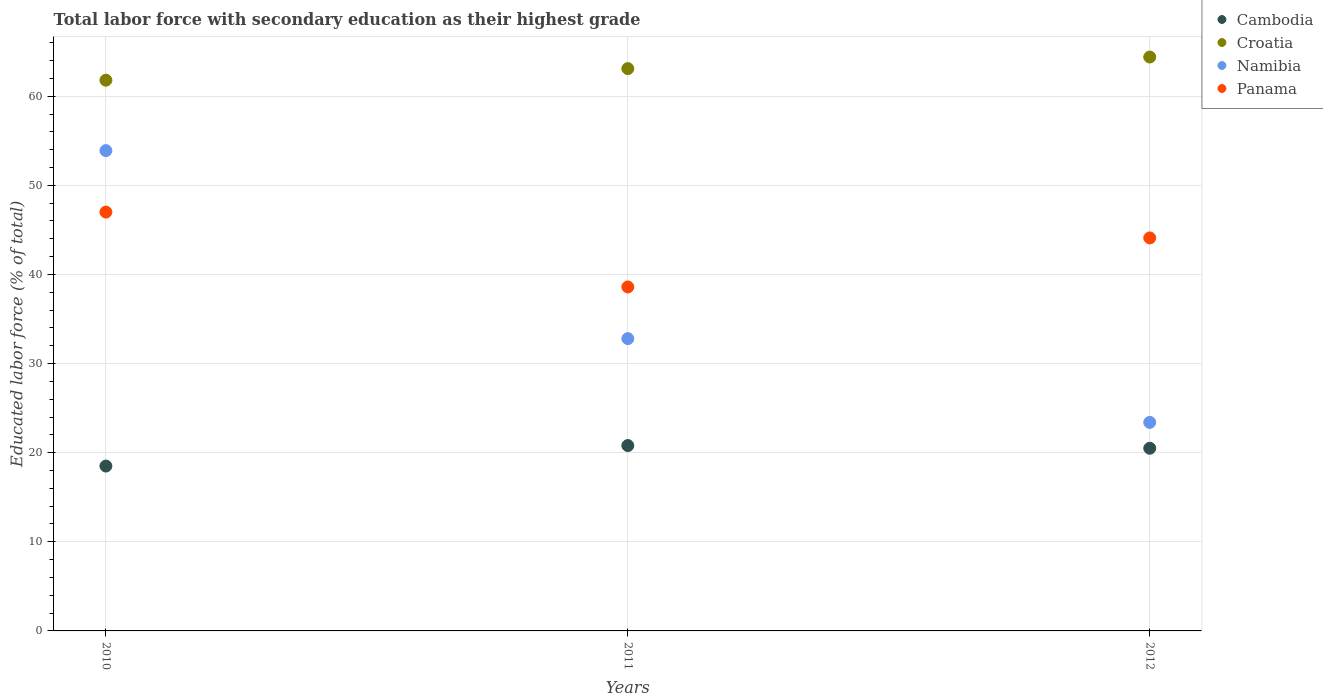Across all years, what is the maximum percentage of total labor force with primary education in Cambodia?
Ensure brevity in your answer.  20.8. Across all years, what is the minimum percentage of total labor force with primary education in Panama?
Your answer should be very brief. 38.6. In which year was the percentage of total labor force with primary education in Croatia maximum?
Ensure brevity in your answer.  2012. What is the total percentage of total labor force with primary education in Namibia in the graph?
Offer a very short reply. 110.1. What is the difference between the percentage of total labor force with primary education in Croatia in 2010 and that in 2011?
Your answer should be compact. -1.3. What is the difference between the percentage of total labor force with primary education in Cambodia in 2012 and the percentage of total labor force with primary education in Panama in 2010?
Offer a terse response. -26.5. What is the average percentage of total labor force with primary education in Croatia per year?
Provide a short and direct response. 63.1. What is the ratio of the percentage of total labor force with primary education in Croatia in 2010 to that in 2011?
Ensure brevity in your answer.  0.98. Is the difference between the percentage of total labor force with primary education in Panama in 2010 and 2011 greater than the difference between the percentage of total labor force with primary education in Cambodia in 2010 and 2011?
Provide a succinct answer. Yes. What is the difference between the highest and the second highest percentage of total labor force with primary education in Cambodia?
Your answer should be very brief. 0.3. What is the difference between the highest and the lowest percentage of total labor force with primary education in Namibia?
Offer a very short reply. 30.5. In how many years, is the percentage of total labor force with primary education in Namibia greater than the average percentage of total labor force with primary education in Namibia taken over all years?
Ensure brevity in your answer.  1. Is the sum of the percentage of total labor force with primary education in Cambodia in 2010 and 2011 greater than the maximum percentage of total labor force with primary education in Namibia across all years?
Keep it short and to the point. No. Is it the case that in every year, the sum of the percentage of total labor force with primary education in Namibia and percentage of total labor force with primary education in Cambodia  is greater than the sum of percentage of total labor force with primary education in Panama and percentage of total labor force with primary education in Croatia?
Your answer should be compact. Yes. Is it the case that in every year, the sum of the percentage of total labor force with primary education in Croatia and percentage of total labor force with primary education in Cambodia  is greater than the percentage of total labor force with primary education in Namibia?
Offer a very short reply. Yes. How many dotlines are there?
Your answer should be compact. 4. How many years are there in the graph?
Keep it short and to the point. 3. Are the values on the major ticks of Y-axis written in scientific E-notation?
Make the answer very short. No. Where does the legend appear in the graph?
Give a very brief answer. Top right. How many legend labels are there?
Offer a very short reply. 4. What is the title of the graph?
Ensure brevity in your answer.  Total labor force with secondary education as their highest grade. What is the label or title of the Y-axis?
Keep it short and to the point. Educated labor force (% of total). What is the Educated labor force (% of total) of Cambodia in 2010?
Your answer should be compact. 18.5. What is the Educated labor force (% of total) in Croatia in 2010?
Provide a succinct answer. 61.8. What is the Educated labor force (% of total) of Namibia in 2010?
Make the answer very short. 53.9. What is the Educated labor force (% of total) in Panama in 2010?
Provide a short and direct response. 47. What is the Educated labor force (% of total) of Cambodia in 2011?
Your answer should be very brief. 20.8. What is the Educated labor force (% of total) of Croatia in 2011?
Your answer should be compact. 63.1. What is the Educated labor force (% of total) in Namibia in 2011?
Make the answer very short. 32.8. What is the Educated labor force (% of total) of Panama in 2011?
Give a very brief answer. 38.6. What is the Educated labor force (% of total) in Croatia in 2012?
Your answer should be very brief. 64.4. What is the Educated labor force (% of total) in Namibia in 2012?
Your answer should be compact. 23.4. What is the Educated labor force (% of total) of Panama in 2012?
Make the answer very short. 44.1. Across all years, what is the maximum Educated labor force (% of total) in Cambodia?
Offer a very short reply. 20.8. Across all years, what is the maximum Educated labor force (% of total) in Croatia?
Your answer should be very brief. 64.4. Across all years, what is the maximum Educated labor force (% of total) in Namibia?
Give a very brief answer. 53.9. Across all years, what is the minimum Educated labor force (% of total) of Cambodia?
Keep it short and to the point. 18.5. Across all years, what is the minimum Educated labor force (% of total) of Croatia?
Your response must be concise. 61.8. Across all years, what is the minimum Educated labor force (% of total) of Namibia?
Give a very brief answer. 23.4. Across all years, what is the minimum Educated labor force (% of total) of Panama?
Your answer should be very brief. 38.6. What is the total Educated labor force (% of total) in Cambodia in the graph?
Ensure brevity in your answer.  59.8. What is the total Educated labor force (% of total) in Croatia in the graph?
Your response must be concise. 189.3. What is the total Educated labor force (% of total) of Namibia in the graph?
Offer a very short reply. 110.1. What is the total Educated labor force (% of total) in Panama in the graph?
Make the answer very short. 129.7. What is the difference between the Educated labor force (% of total) of Namibia in 2010 and that in 2011?
Keep it short and to the point. 21.1. What is the difference between the Educated labor force (% of total) of Panama in 2010 and that in 2011?
Offer a terse response. 8.4. What is the difference between the Educated labor force (% of total) in Croatia in 2010 and that in 2012?
Your answer should be compact. -2.6. What is the difference between the Educated labor force (% of total) in Namibia in 2010 and that in 2012?
Your answer should be compact. 30.5. What is the difference between the Educated labor force (% of total) in Croatia in 2011 and that in 2012?
Your response must be concise. -1.3. What is the difference between the Educated labor force (% of total) in Namibia in 2011 and that in 2012?
Provide a short and direct response. 9.4. What is the difference between the Educated labor force (% of total) of Panama in 2011 and that in 2012?
Provide a short and direct response. -5.5. What is the difference between the Educated labor force (% of total) in Cambodia in 2010 and the Educated labor force (% of total) in Croatia in 2011?
Give a very brief answer. -44.6. What is the difference between the Educated labor force (% of total) of Cambodia in 2010 and the Educated labor force (% of total) of Namibia in 2011?
Offer a terse response. -14.3. What is the difference between the Educated labor force (% of total) of Cambodia in 2010 and the Educated labor force (% of total) of Panama in 2011?
Your answer should be compact. -20.1. What is the difference between the Educated labor force (% of total) in Croatia in 2010 and the Educated labor force (% of total) in Namibia in 2011?
Offer a very short reply. 29. What is the difference between the Educated labor force (% of total) of Croatia in 2010 and the Educated labor force (% of total) of Panama in 2011?
Offer a very short reply. 23.2. What is the difference between the Educated labor force (% of total) in Namibia in 2010 and the Educated labor force (% of total) in Panama in 2011?
Provide a succinct answer. 15.3. What is the difference between the Educated labor force (% of total) of Cambodia in 2010 and the Educated labor force (% of total) of Croatia in 2012?
Ensure brevity in your answer.  -45.9. What is the difference between the Educated labor force (% of total) in Cambodia in 2010 and the Educated labor force (% of total) in Namibia in 2012?
Make the answer very short. -4.9. What is the difference between the Educated labor force (% of total) of Cambodia in 2010 and the Educated labor force (% of total) of Panama in 2012?
Ensure brevity in your answer.  -25.6. What is the difference between the Educated labor force (% of total) of Croatia in 2010 and the Educated labor force (% of total) of Namibia in 2012?
Give a very brief answer. 38.4. What is the difference between the Educated labor force (% of total) of Croatia in 2010 and the Educated labor force (% of total) of Panama in 2012?
Ensure brevity in your answer.  17.7. What is the difference between the Educated labor force (% of total) in Cambodia in 2011 and the Educated labor force (% of total) in Croatia in 2012?
Your answer should be very brief. -43.6. What is the difference between the Educated labor force (% of total) of Cambodia in 2011 and the Educated labor force (% of total) of Namibia in 2012?
Make the answer very short. -2.6. What is the difference between the Educated labor force (% of total) in Cambodia in 2011 and the Educated labor force (% of total) in Panama in 2012?
Provide a succinct answer. -23.3. What is the difference between the Educated labor force (% of total) of Croatia in 2011 and the Educated labor force (% of total) of Namibia in 2012?
Provide a succinct answer. 39.7. What is the difference between the Educated labor force (% of total) in Croatia in 2011 and the Educated labor force (% of total) in Panama in 2012?
Keep it short and to the point. 19. What is the difference between the Educated labor force (% of total) of Namibia in 2011 and the Educated labor force (% of total) of Panama in 2012?
Offer a very short reply. -11.3. What is the average Educated labor force (% of total) in Cambodia per year?
Ensure brevity in your answer.  19.93. What is the average Educated labor force (% of total) in Croatia per year?
Your answer should be very brief. 63.1. What is the average Educated labor force (% of total) of Namibia per year?
Your answer should be very brief. 36.7. What is the average Educated labor force (% of total) in Panama per year?
Your response must be concise. 43.23. In the year 2010, what is the difference between the Educated labor force (% of total) in Cambodia and Educated labor force (% of total) in Croatia?
Your answer should be compact. -43.3. In the year 2010, what is the difference between the Educated labor force (% of total) in Cambodia and Educated labor force (% of total) in Namibia?
Make the answer very short. -35.4. In the year 2010, what is the difference between the Educated labor force (% of total) in Cambodia and Educated labor force (% of total) in Panama?
Offer a terse response. -28.5. In the year 2010, what is the difference between the Educated labor force (% of total) in Namibia and Educated labor force (% of total) in Panama?
Ensure brevity in your answer.  6.9. In the year 2011, what is the difference between the Educated labor force (% of total) of Cambodia and Educated labor force (% of total) of Croatia?
Offer a terse response. -42.3. In the year 2011, what is the difference between the Educated labor force (% of total) in Cambodia and Educated labor force (% of total) in Namibia?
Offer a very short reply. -12. In the year 2011, what is the difference between the Educated labor force (% of total) in Cambodia and Educated labor force (% of total) in Panama?
Your answer should be very brief. -17.8. In the year 2011, what is the difference between the Educated labor force (% of total) of Croatia and Educated labor force (% of total) of Namibia?
Ensure brevity in your answer.  30.3. In the year 2011, what is the difference between the Educated labor force (% of total) of Namibia and Educated labor force (% of total) of Panama?
Provide a short and direct response. -5.8. In the year 2012, what is the difference between the Educated labor force (% of total) in Cambodia and Educated labor force (% of total) in Croatia?
Ensure brevity in your answer.  -43.9. In the year 2012, what is the difference between the Educated labor force (% of total) of Cambodia and Educated labor force (% of total) of Namibia?
Give a very brief answer. -2.9. In the year 2012, what is the difference between the Educated labor force (% of total) of Cambodia and Educated labor force (% of total) of Panama?
Your answer should be compact. -23.6. In the year 2012, what is the difference between the Educated labor force (% of total) of Croatia and Educated labor force (% of total) of Namibia?
Your response must be concise. 41. In the year 2012, what is the difference between the Educated labor force (% of total) of Croatia and Educated labor force (% of total) of Panama?
Offer a very short reply. 20.3. In the year 2012, what is the difference between the Educated labor force (% of total) in Namibia and Educated labor force (% of total) in Panama?
Your answer should be very brief. -20.7. What is the ratio of the Educated labor force (% of total) in Cambodia in 2010 to that in 2011?
Provide a succinct answer. 0.89. What is the ratio of the Educated labor force (% of total) in Croatia in 2010 to that in 2011?
Offer a terse response. 0.98. What is the ratio of the Educated labor force (% of total) in Namibia in 2010 to that in 2011?
Your response must be concise. 1.64. What is the ratio of the Educated labor force (% of total) of Panama in 2010 to that in 2011?
Your answer should be compact. 1.22. What is the ratio of the Educated labor force (% of total) of Cambodia in 2010 to that in 2012?
Offer a very short reply. 0.9. What is the ratio of the Educated labor force (% of total) of Croatia in 2010 to that in 2012?
Give a very brief answer. 0.96. What is the ratio of the Educated labor force (% of total) of Namibia in 2010 to that in 2012?
Offer a very short reply. 2.3. What is the ratio of the Educated labor force (% of total) in Panama in 2010 to that in 2012?
Your response must be concise. 1.07. What is the ratio of the Educated labor force (% of total) of Cambodia in 2011 to that in 2012?
Provide a succinct answer. 1.01. What is the ratio of the Educated labor force (% of total) in Croatia in 2011 to that in 2012?
Provide a short and direct response. 0.98. What is the ratio of the Educated labor force (% of total) in Namibia in 2011 to that in 2012?
Provide a succinct answer. 1.4. What is the ratio of the Educated labor force (% of total) of Panama in 2011 to that in 2012?
Your answer should be very brief. 0.88. What is the difference between the highest and the second highest Educated labor force (% of total) of Cambodia?
Provide a succinct answer. 0.3. What is the difference between the highest and the second highest Educated labor force (% of total) in Namibia?
Your response must be concise. 21.1. What is the difference between the highest and the second highest Educated labor force (% of total) of Panama?
Make the answer very short. 2.9. What is the difference between the highest and the lowest Educated labor force (% of total) of Namibia?
Ensure brevity in your answer.  30.5. What is the difference between the highest and the lowest Educated labor force (% of total) in Panama?
Keep it short and to the point. 8.4. 